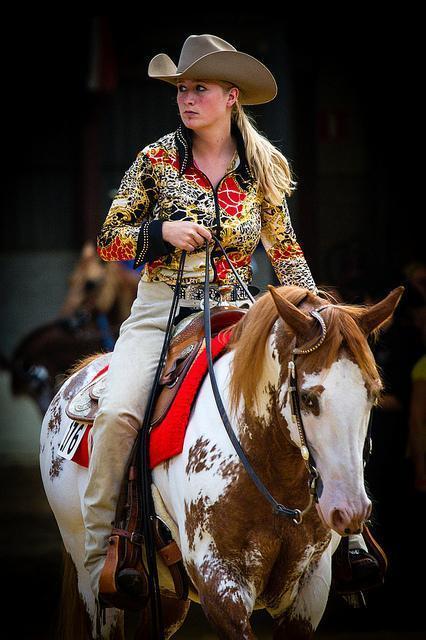How many horses are there?
Give a very brief answer. 1. How many zebra are here?
Give a very brief answer. 0. 